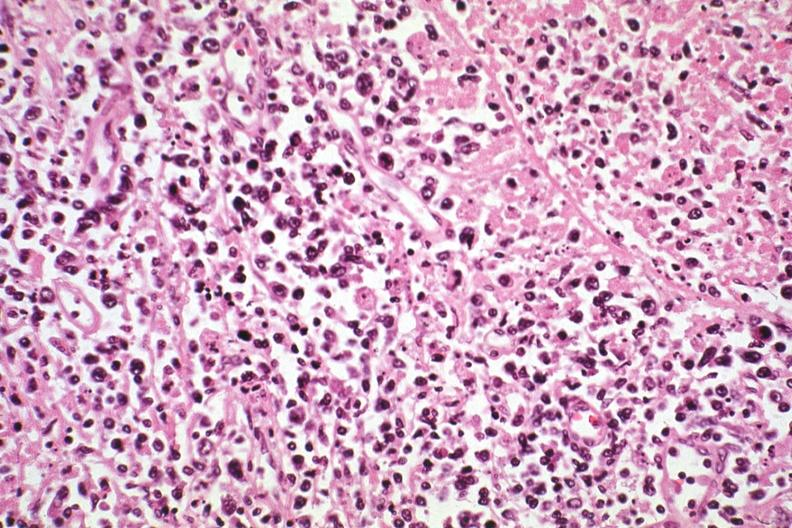s leiomyosarcoma present?
Answer the question using a single word or phrase. No 